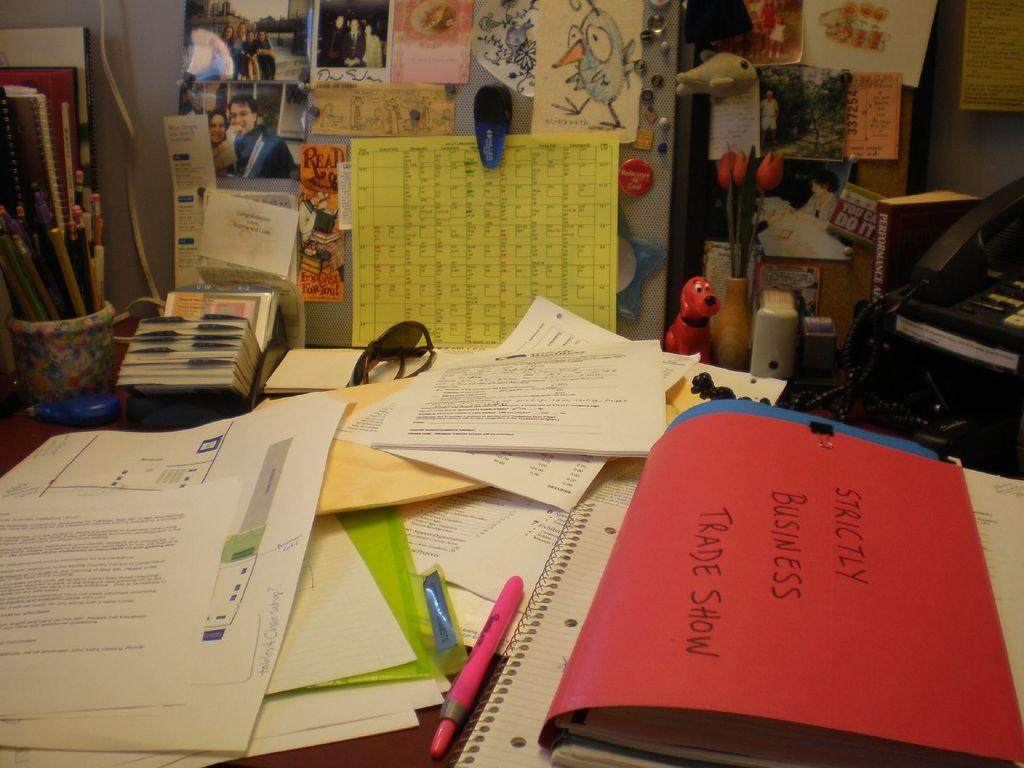<image>
Share a concise interpretation of the image provided. A desk cluttered with papers and a red folder that says Strictly Business on it. 